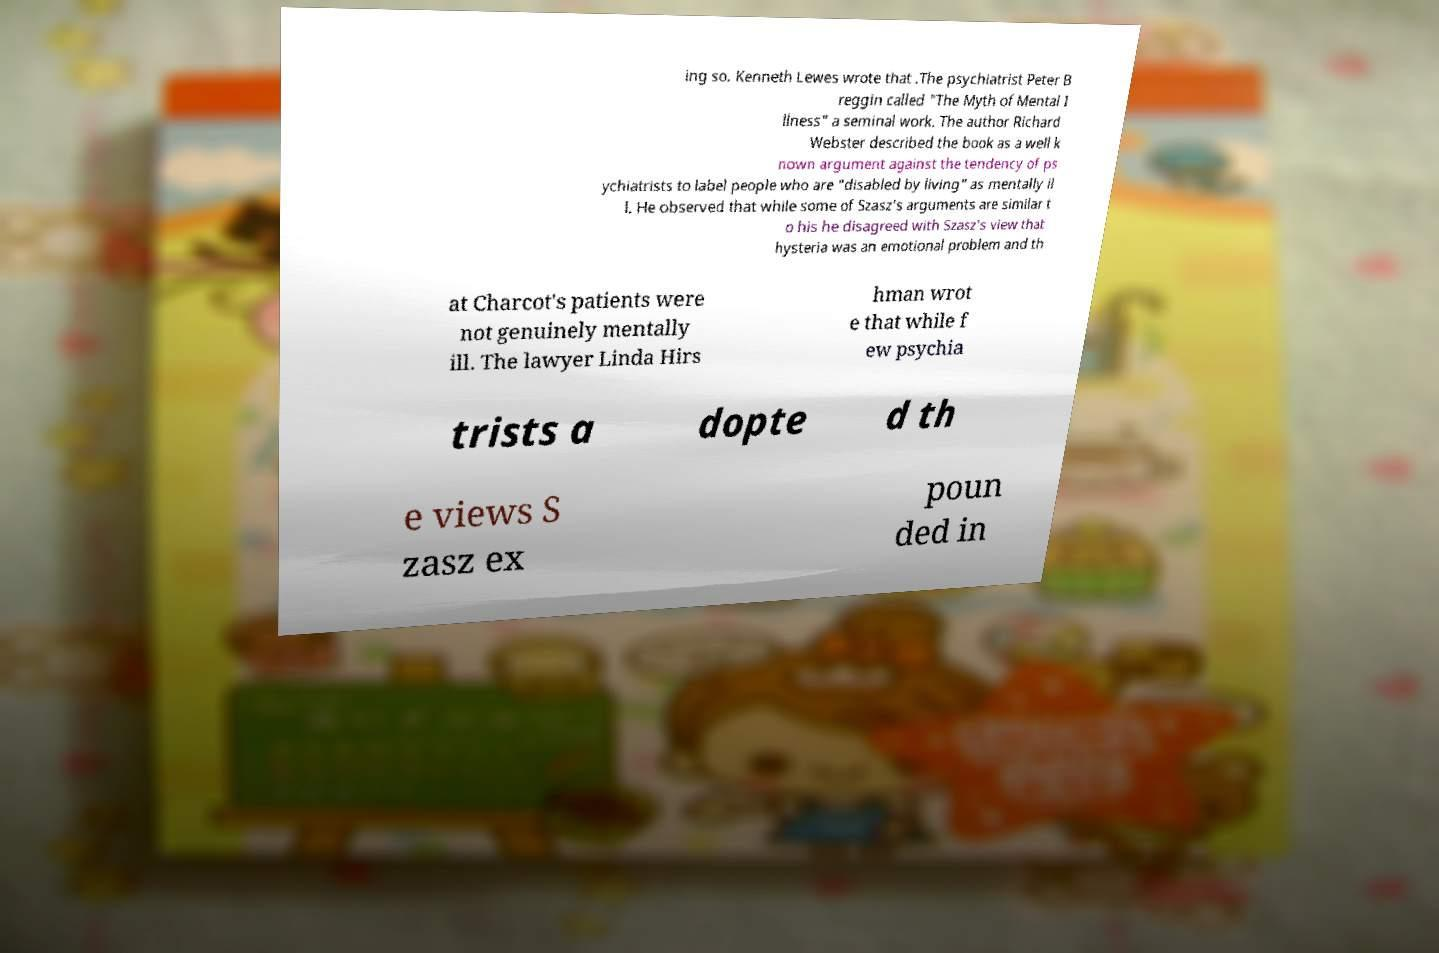I need the written content from this picture converted into text. Can you do that? ing so. Kenneth Lewes wrote that .The psychiatrist Peter B reggin called "The Myth of Mental I llness" a seminal work. The author Richard Webster described the book as a well k nown argument against the tendency of ps ychiatrists to label people who are "disabled by living" as mentally il l. He observed that while some of Szasz's arguments are similar t o his he disagreed with Szasz's view that hysteria was an emotional problem and th at Charcot's patients were not genuinely mentally ill. The lawyer Linda Hirs hman wrot e that while f ew psychia trists a dopte d th e views S zasz ex poun ded in 